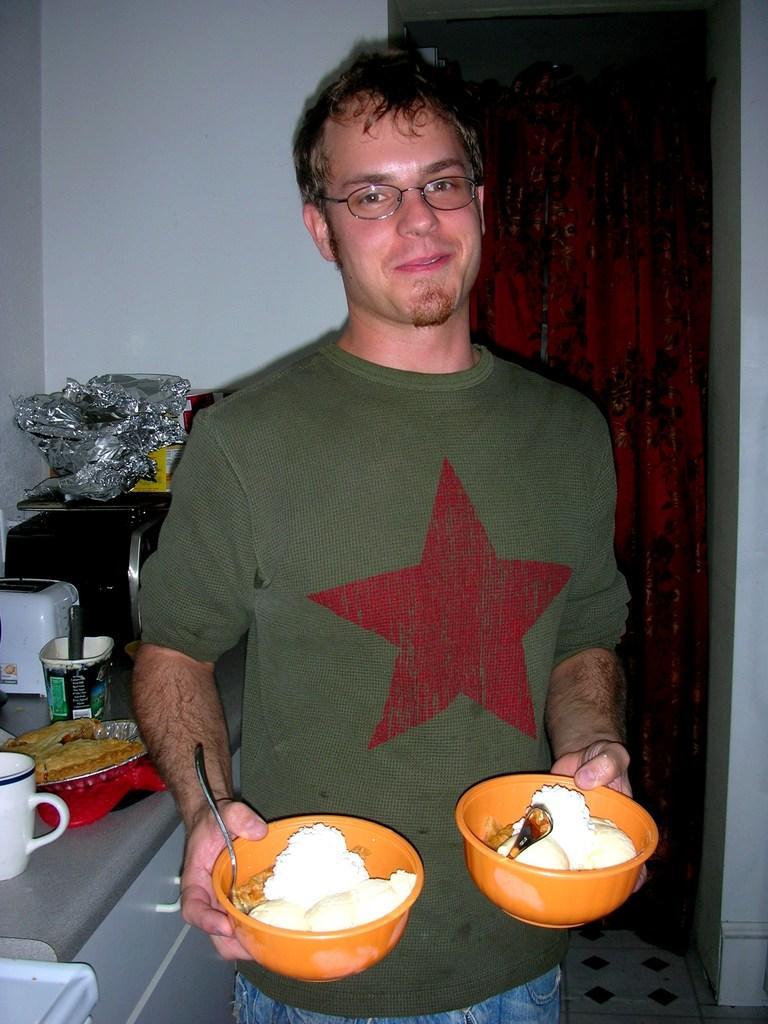How would you summarize this image in a sentence or two? In the center of the image there is a person standing and holding a food in bowls. On the left side of the image we can see microwave oven, bread maker on countertop. In the background we can see curtain and wall. 